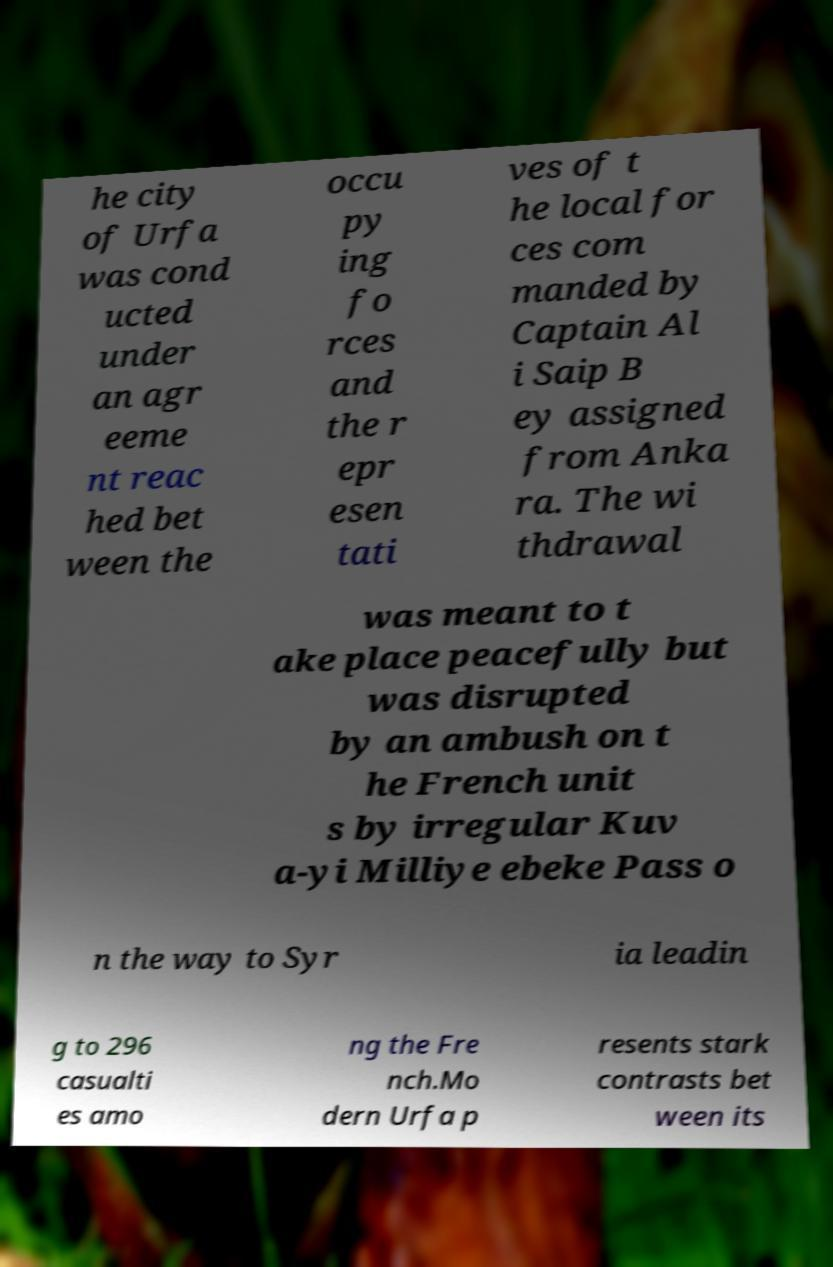What messages or text are displayed in this image? I need them in a readable, typed format. he city of Urfa was cond ucted under an agr eeme nt reac hed bet ween the occu py ing fo rces and the r epr esen tati ves of t he local for ces com manded by Captain Al i Saip B ey assigned from Anka ra. The wi thdrawal was meant to t ake place peacefully but was disrupted by an ambush on t he French unit s by irregular Kuv a-yi Milliye ebeke Pass o n the way to Syr ia leadin g to 296 casualti es amo ng the Fre nch.Mo dern Urfa p resents stark contrasts bet ween its 